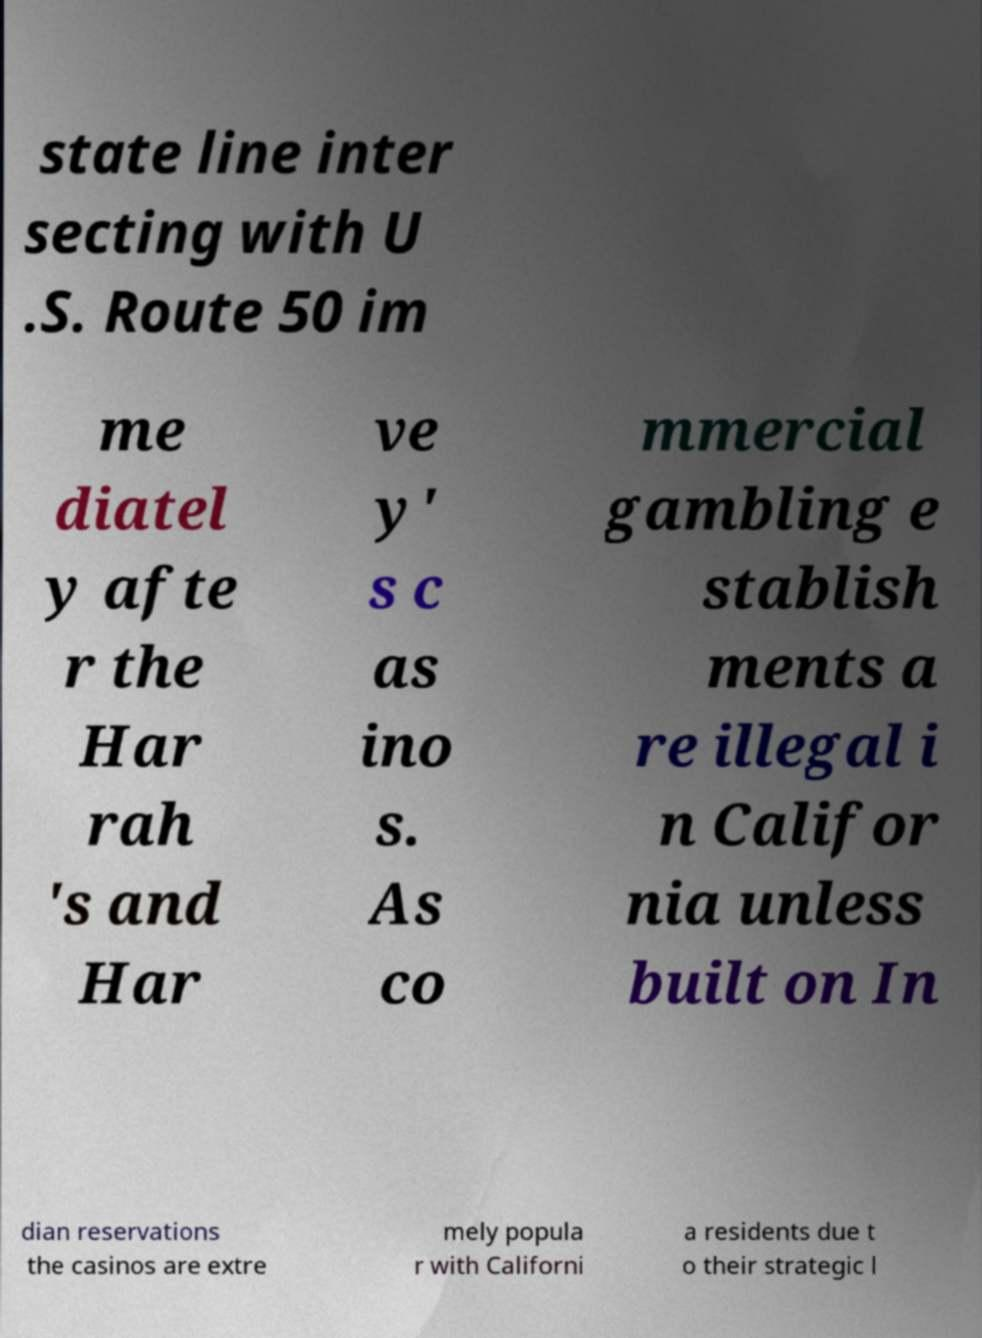Please identify and transcribe the text found in this image. state line inter secting with U .S. Route 50 im me diatel y afte r the Har rah 's and Har ve y' s c as ino s. As co mmercial gambling e stablish ments a re illegal i n Califor nia unless built on In dian reservations the casinos are extre mely popula r with Californi a residents due t o their strategic l 